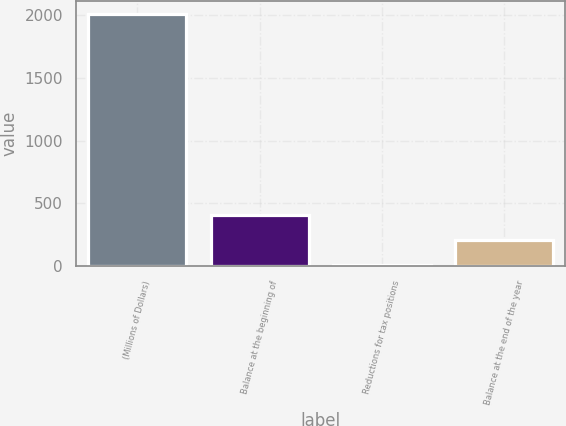Convert chart to OTSL. <chart><loc_0><loc_0><loc_500><loc_500><bar_chart><fcel>(Millions of Dollars)<fcel>Balance at the beginning of<fcel>Reductions for tax positions<fcel>Balance at the end of the year<nl><fcel>2008<fcel>412<fcel>13<fcel>212.5<nl></chart> 